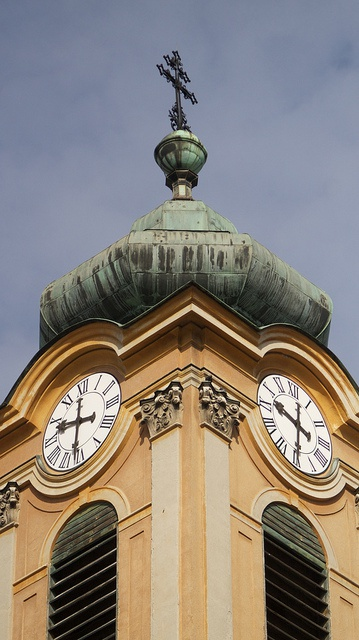Describe the objects in this image and their specific colors. I can see clock in gray, ivory, tan, and maroon tones and clock in gray, ivory, darkgray, and tan tones in this image. 